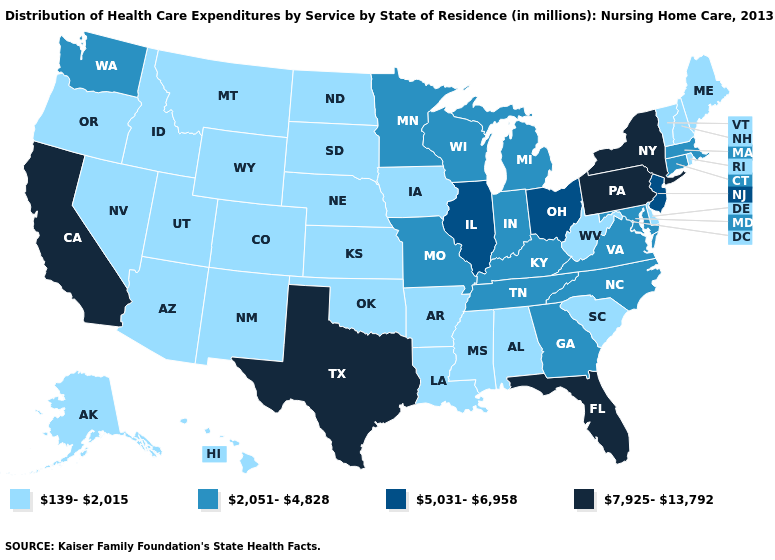Which states hav the highest value in the MidWest?
Keep it brief. Illinois, Ohio. Does Missouri have the same value as Minnesota?
Concise answer only. Yes. What is the lowest value in the MidWest?
Quick response, please. 139-2,015. Among the states that border Georgia , does South Carolina have the lowest value?
Give a very brief answer. Yes. What is the highest value in the USA?
Concise answer only. 7,925-13,792. What is the value of Missouri?
Give a very brief answer. 2,051-4,828. Among the states that border South Dakota , does Minnesota have the highest value?
Give a very brief answer. Yes. Name the states that have a value in the range 139-2,015?
Quick response, please. Alabama, Alaska, Arizona, Arkansas, Colorado, Delaware, Hawaii, Idaho, Iowa, Kansas, Louisiana, Maine, Mississippi, Montana, Nebraska, Nevada, New Hampshire, New Mexico, North Dakota, Oklahoma, Oregon, Rhode Island, South Carolina, South Dakota, Utah, Vermont, West Virginia, Wyoming. Does the map have missing data?
Answer briefly. No. Which states hav the highest value in the South?
Be succinct. Florida, Texas. Does Illinois have the lowest value in the MidWest?
Be succinct. No. Name the states that have a value in the range 5,031-6,958?
Short answer required. Illinois, New Jersey, Ohio. Among the states that border New Jersey , which have the highest value?
Short answer required. New York, Pennsylvania. Among the states that border Oklahoma , does New Mexico have the highest value?
Concise answer only. No. Does Hawaii have the highest value in the West?
Keep it brief. No. 